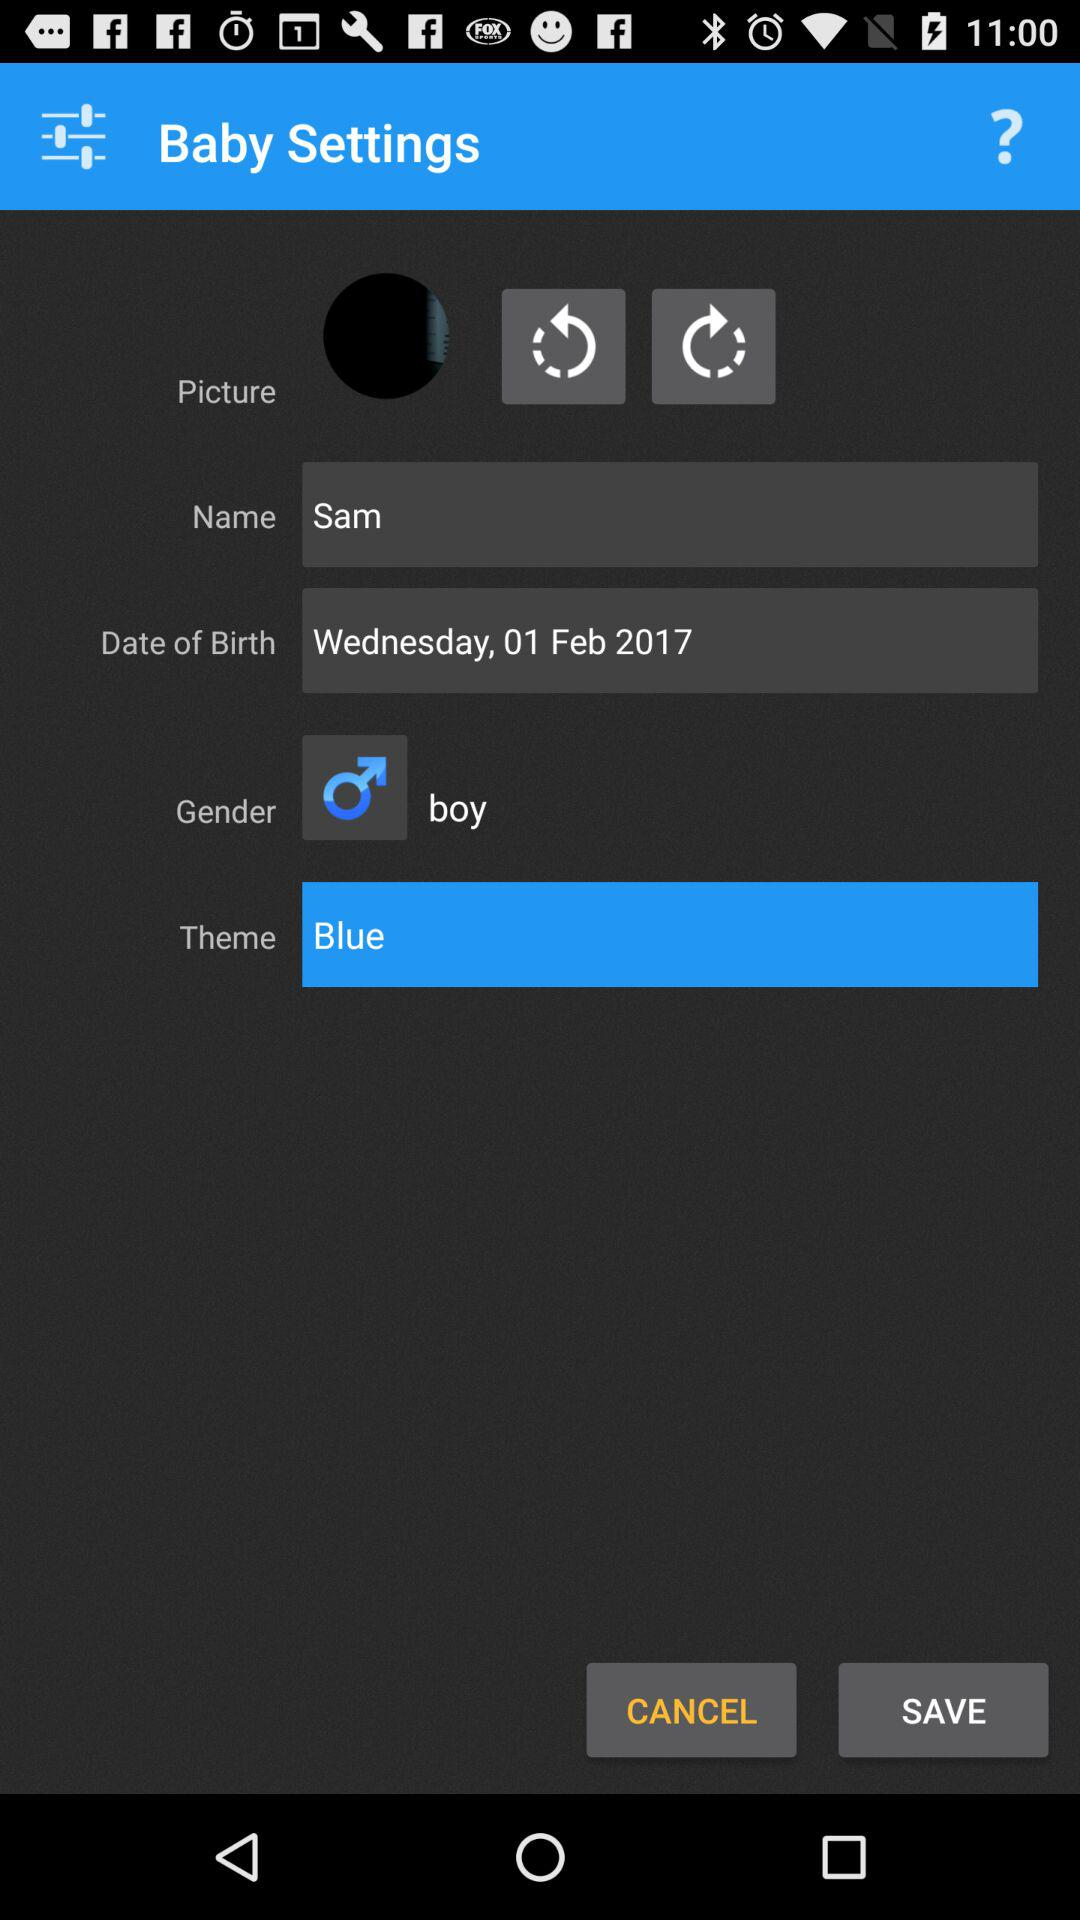What is the date of birth? The date of birth is Wednesday, February 1, 2017. 